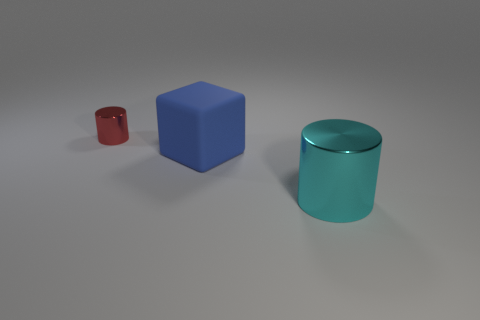What kind of lighting setup might have been used to achieve the shadows and highlights on these objects? The image appears to have a soft-lighting setup possibly using global illumination, which creates subtle shadows and reflects light realistically across the surfaces of the objects. This technique is often used in 3D rendering to simulate the complex light interactions seen in real-life environments. 